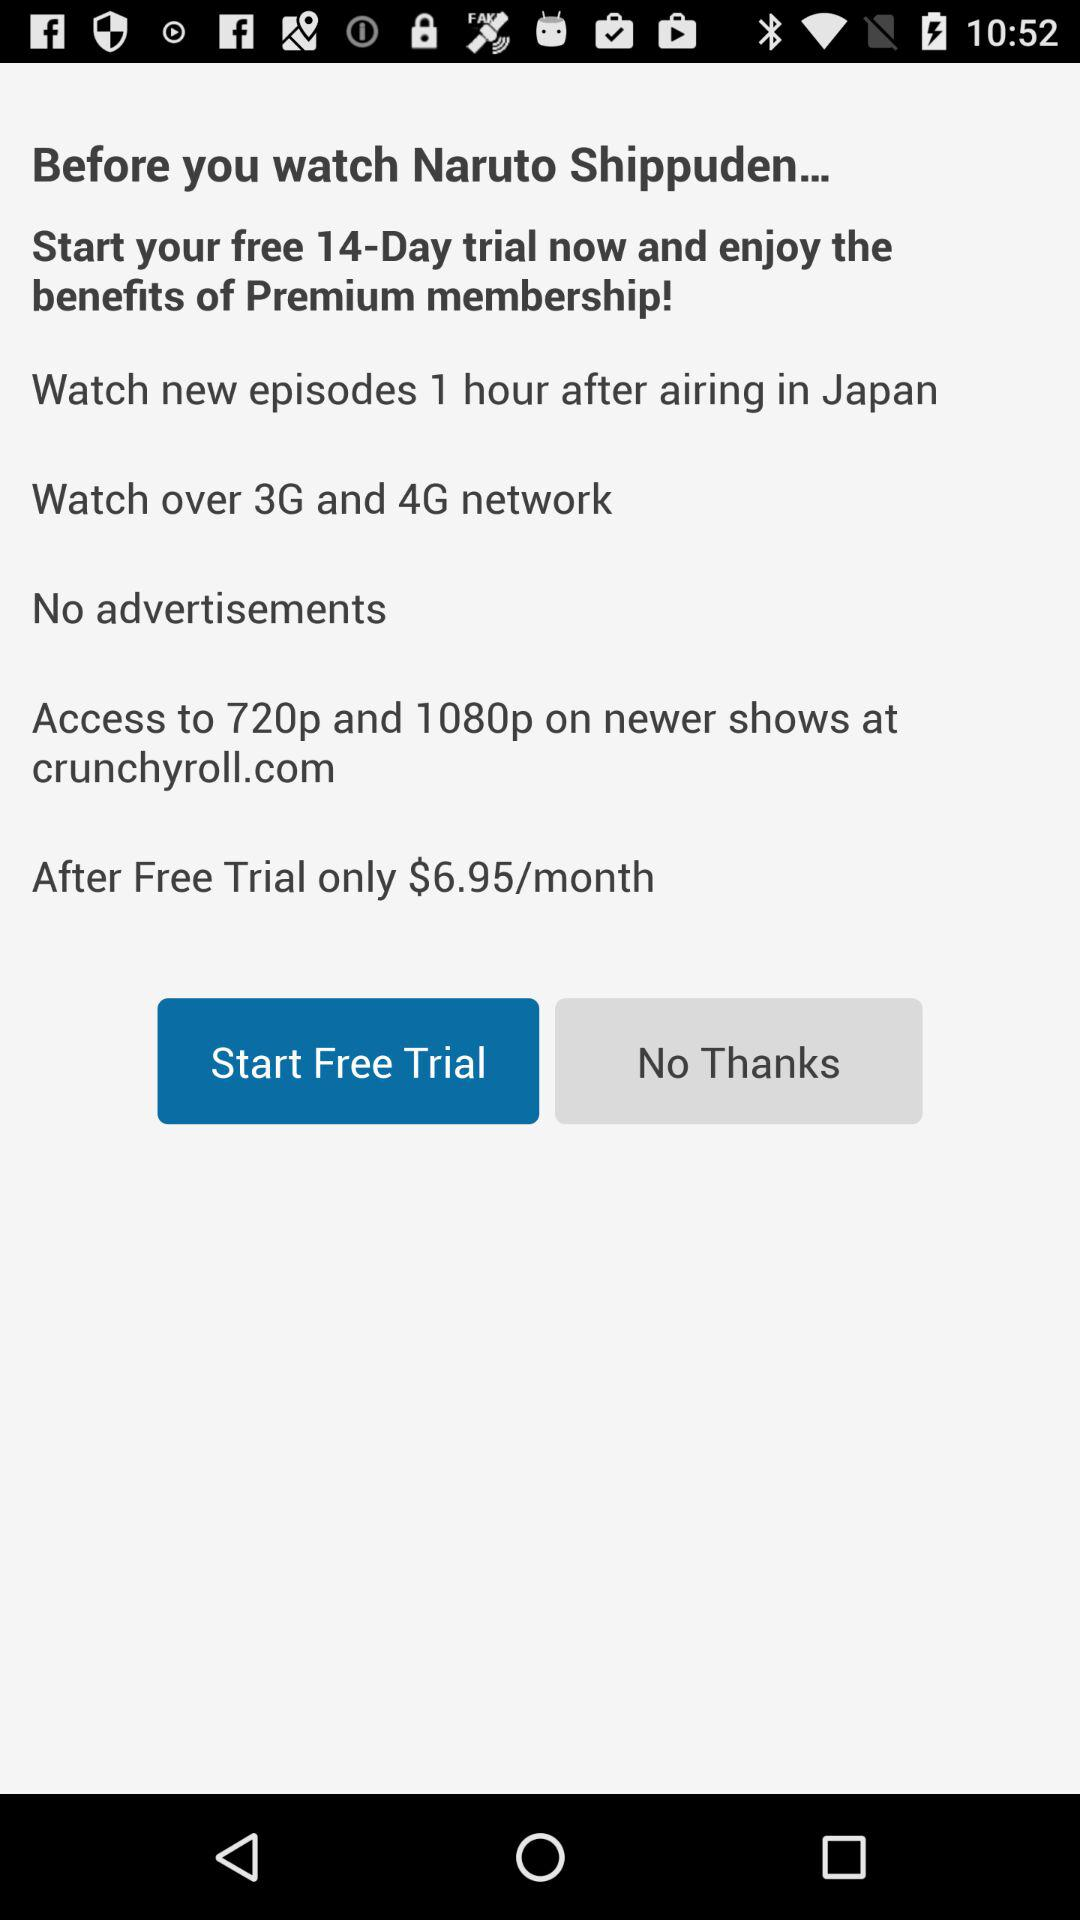What is the cost after the free trial? The cost after the free trial is $6.95 per month. 